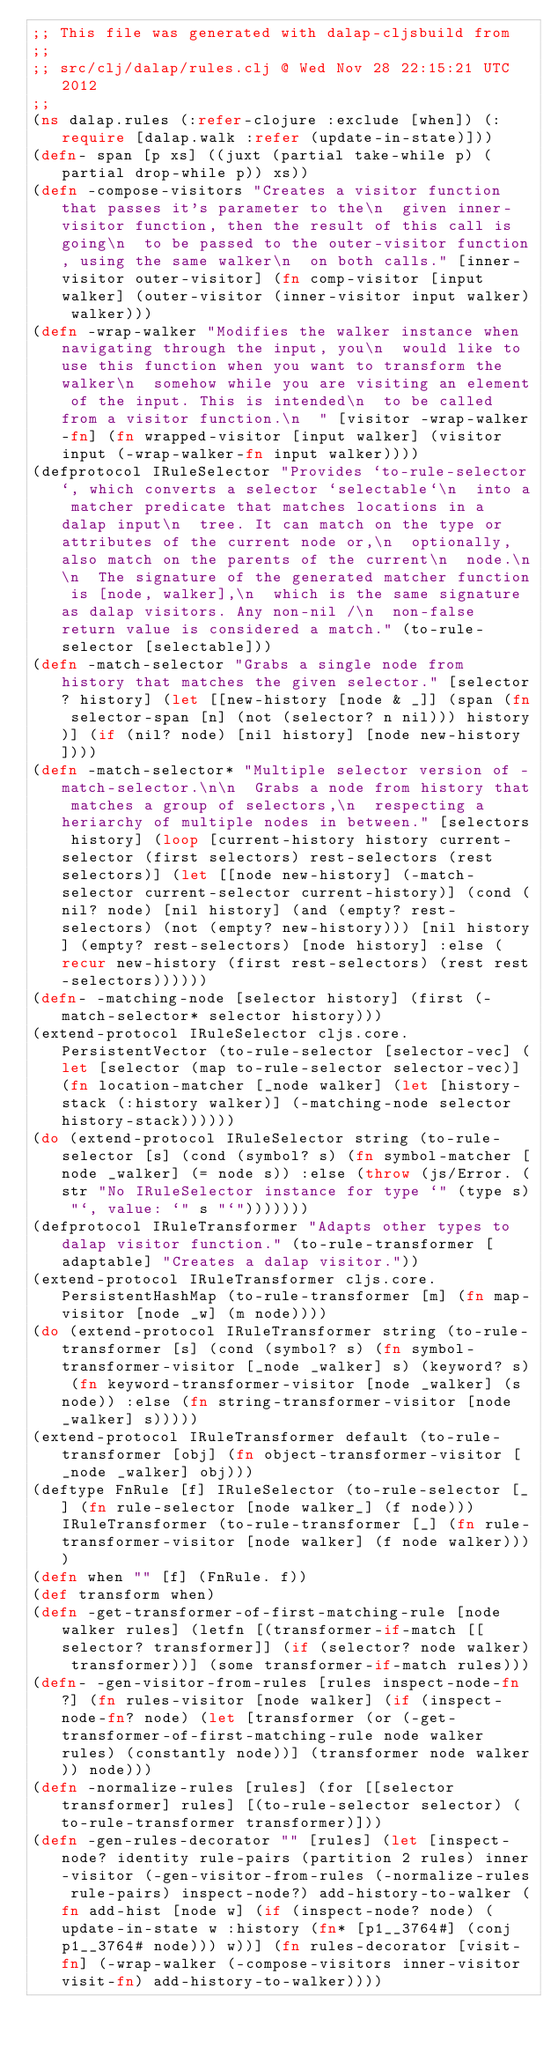Convert code to text. <code><loc_0><loc_0><loc_500><loc_500><_Clojure_>;; This file was generated with dalap-cljsbuild from
;;
;; src/clj/dalap/rules.clj @ Wed Nov 28 22:15:21 UTC 2012
;;
(ns dalap.rules (:refer-clojure :exclude [when]) (:require [dalap.walk :refer (update-in-state)]))
(defn- span [p xs] ((juxt (partial take-while p) (partial drop-while p)) xs))
(defn -compose-visitors "Creates a visitor function that passes it's parameter to the\n  given inner-visitor function, then the result of this call is going\n  to be passed to the outer-visitor function, using the same walker\n  on both calls." [inner-visitor outer-visitor] (fn comp-visitor [input walker] (outer-visitor (inner-visitor input walker) walker)))
(defn -wrap-walker "Modifies the walker instance when navigating through the input, you\n  would like to use this function when you want to transform the walker\n  somehow while you are visiting an element of the input. This is intended\n  to be called from a visitor function.\n  " [visitor -wrap-walker-fn] (fn wrapped-visitor [input walker] (visitor input (-wrap-walker-fn input walker))))
(defprotocol IRuleSelector "Provides `to-rule-selector`, which converts a selector `selectable`\n  into a matcher predicate that matches locations in a dalap input\n  tree. It can match on the type or attributes of the current node or,\n  optionally, also match on the parents of the current\n  node.\n\n  The signature of the generated matcher function is [node, walker],\n  which is the same signature as dalap visitors. Any non-nil /\n  non-false return value is considered a match." (to-rule-selector [selectable]))
(defn -match-selector "Grabs a single node from history that matches the given selector." [selector? history] (let [[new-history [node & _]] (span (fn selector-span [n] (not (selector? n nil))) history)] (if (nil? node) [nil history] [node new-history])))
(defn -match-selector* "Multiple selector version of -match-selector.\n\n  Grabs a node from history that matches a group of selectors,\n  respecting a heriarchy of multiple nodes in between." [selectors history] (loop [current-history history current-selector (first selectors) rest-selectors (rest selectors)] (let [[node new-history] (-match-selector current-selector current-history)] (cond (nil? node) [nil history] (and (empty? rest-selectors) (not (empty? new-history))) [nil history] (empty? rest-selectors) [node history] :else (recur new-history (first rest-selectors) (rest rest-selectors))))))
(defn- -matching-node [selector history] (first (-match-selector* selector history)))
(extend-protocol IRuleSelector cljs.core.PersistentVector (to-rule-selector [selector-vec] (let [selector (map to-rule-selector selector-vec)] (fn location-matcher [_node walker] (let [history-stack (:history walker)] (-matching-node selector history-stack))))))
(do (extend-protocol IRuleSelector string (to-rule-selector [s] (cond (symbol? s) (fn symbol-matcher [node _walker] (= node s)) :else (throw (js/Error. (str "No IRuleSelector instance for type `" (type s) "`, value: `" s "`")))))))
(defprotocol IRuleTransformer "Adapts other types to dalap visitor function." (to-rule-transformer [adaptable] "Creates a dalap visitor."))
(extend-protocol IRuleTransformer cljs.core.PersistentHashMap (to-rule-transformer [m] (fn map-visitor [node _w] (m node))))
(do (extend-protocol IRuleTransformer string (to-rule-transformer [s] (cond (symbol? s) (fn symbol-transformer-visitor [_node _walker] s) (keyword? s) (fn keyword-transformer-visitor [node _walker] (s node)) :else (fn string-transformer-visitor [node _walker] s)))))
(extend-protocol IRuleTransformer default (to-rule-transformer [obj] (fn object-transformer-visitor [_node _walker] obj)))
(deftype FnRule [f] IRuleSelector (to-rule-selector [_] (fn rule-selector [node walker_] (f node))) IRuleTransformer (to-rule-transformer [_] (fn rule-transformer-visitor [node walker] (f node walker))))
(defn when "" [f] (FnRule. f))
(def transform when)
(defn -get-transformer-of-first-matching-rule [node walker rules] (letfn [(transformer-if-match [[selector? transformer]] (if (selector? node walker) transformer))] (some transformer-if-match rules)))
(defn- -gen-visitor-from-rules [rules inspect-node-fn?] (fn rules-visitor [node walker] (if (inspect-node-fn? node) (let [transformer (or (-get-transformer-of-first-matching-rule node walker rules) (constantly node))] (transformer node walker)) node)))
(defn -normalize-rules [rules] (for [[selector transformer] rules] [(to-rule-selector selector) (to-rule-transformer transformer)]))
(defn -gen-rules-decorator "" [rules] (let [inspect-node? identity rule-pairs (partition 2 rules) inner-visitor (-gen-visitor-from-rules (-normalize-rules rule-pairs) inspect-node?) add-history-to-walker (fn add-hist [node w] (if (inspect-node? node) (update-in-state w :history (fn* [p1__3764#] (conj p1__3764# node))) w))] (fn rules-decorator [visit-fn] (-wrap-walker (-compose-visitors inner-visitor visit-fn) add-history-to-walker))))</code> 